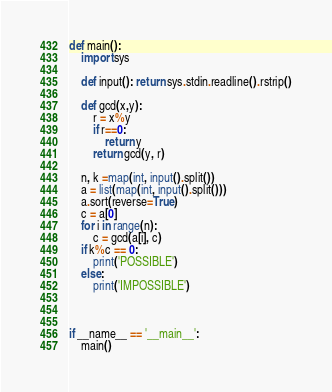<code> <loc_0><loc_0><loc_500><loc_500><_Python_>def main():
    import sys

    def input(): return sys.stdin.readline().rstrip()

    def gcd(x,y):
        r = x%y
        if r==0:
            return y
        return gcd(y, r)

    n, k =map(int, input().split())
    a = list(map(int, input().split()))
    a.sort(reverse=True)
    c = a[0]
    for i in range(n):
        c = gcd(a[i], c)
    if k%c == 0:
        print('POSSIBLE')
    else:
        print('IMPOSSIBLE')
    

    
if __name__ == '__main__':
    main()</code> 